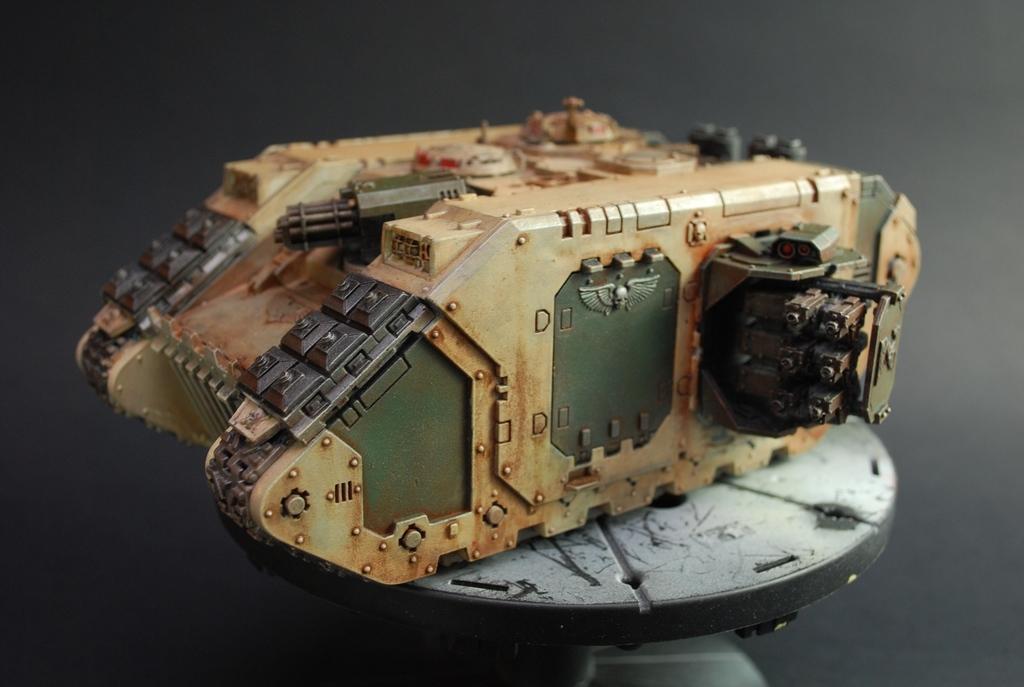Can you describe this image briefly? In this image there is a toy of a panzer on a surface, there is an object towards the bottom of the image, the background of the image is dark. 